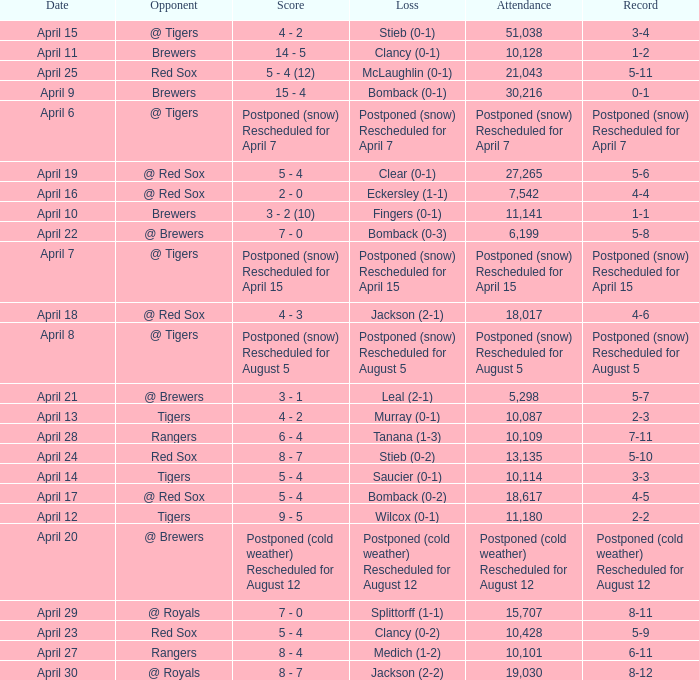What was the date for the game that had an attendance of 10,101? April 27. 